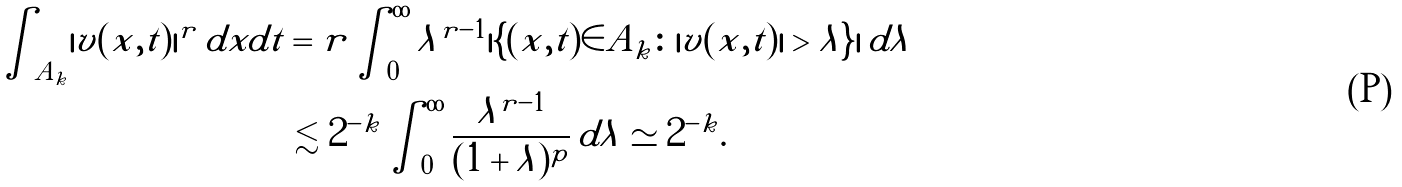Convert formula to latex. <formula><loc_0><loc_0><loc_500><loc_500>\int _ { A _ { k } } | v ( x , t ) | ^ { r } \, d x d t & = r \int _ { 0 } ^ { \infty } \lambda ^ { r - 1 } | \{ ( x , t ) \in A _ { k } \colon | v ( x , t ) | > \lambda \} | \, d \lambda \\ & \lesssim 2 ^ { - k } \int _ { 0 } ^ { \infty } \frac { \lambda ^ { r - 1 } } { ( 1 + \lambda ) ^ { p } } \, d \lambda \simeq 2 ^ { - k } .</formula> 